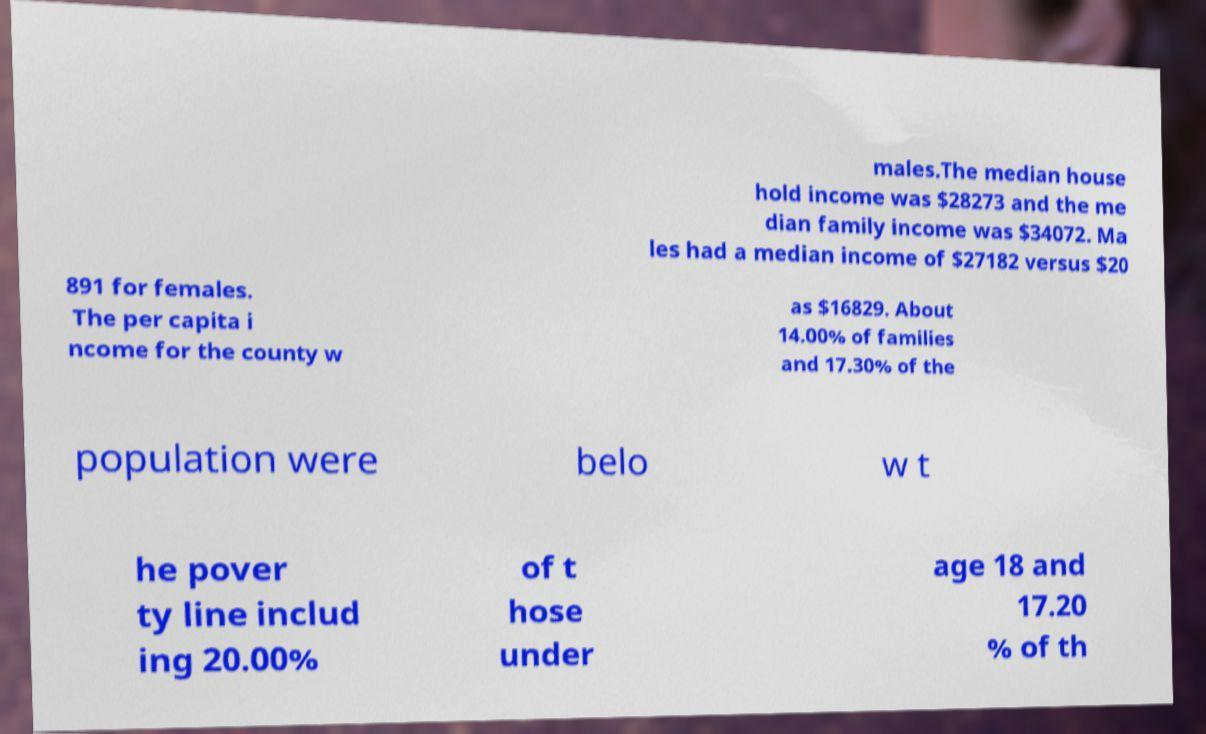Please read and relay the text visible in this image. What does it say? males.The median house hold income was $28273 and the me dian family income was $34072. Ma les had a median income of $27182 versus $20 891 for females. The per capita i ncome for the county w as $16829. About 14.00% of families and 17.30% of the population were belo w t he pover ty line includ ing 20.00% of t hose under age 18 and 17.20 % of th 